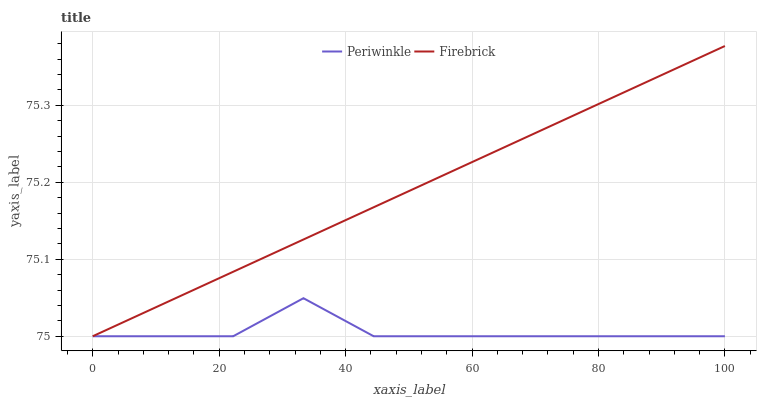Does Periwinkle have the minimum area under the curve?
Answer yes or no. Yes. Does Firebrick have the maximum area under the curve?
Answer yes or no. Yes. Does Periwinkle have the maximum area under the curve?
Answer yes or no. No. Is Firebrick the smoothest?
Answer yes or no. Yes. Is Periwinkle the roughest?
Answer yes or no. Yes. Is Periwinkle the smoothest?
Answer yes or no. No. Does Firebrick have the lowest value?
Answer yes or no. Yes. Does Firebrick have the highest value?
Answer yes or no. Yes. Does Periwinkle have the highest value?
Answer yes or no. No. Does Firebrick intersect Periwinkle?
Answer yes or no. Yes. Is Firebrick less than Periwinkle?
Answer yes or no. No. Is Firebrick greater than Periwinkle?
Answer yes or no. No. 